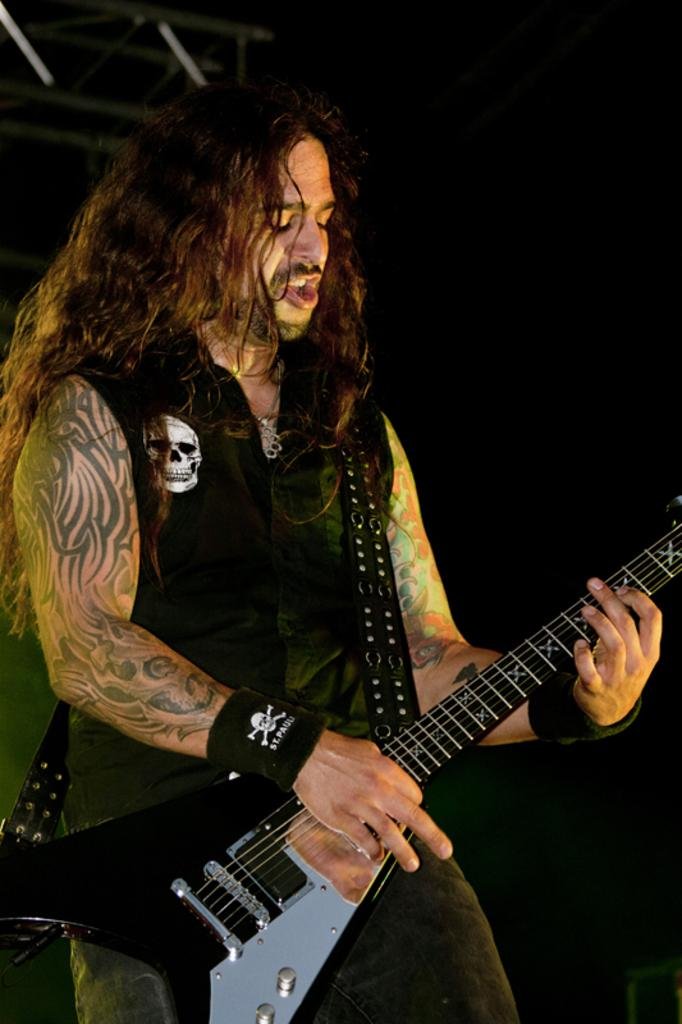Who is the main subject in the image? There is a man in the image. What is the man doing in the image? The man is standing and holding a guitar. What can be observed about the background of the image? The background of the image is dark. What is the plot of the story being told in the image? There is no story being told in the image, as it is a photograph of a man standing and holding a guitar. Can you tell me how many chess pieces are visible in the image? There are no chess pieces present in the image. 